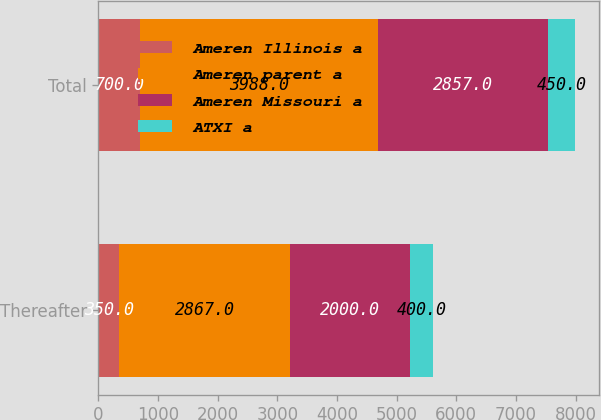<chart> <loc_0><loc_0><loc_500><loc_500><stacked_bar_chart><ecel><fcel>Thereafter<fcel>Total<nl><fcel>Ameren Illinois a<fcel>350<fcel>700<nl><fcel>Ameren parent a<fcel>2867<fcel>3988<nl><fcel>Ameren Missouri a<fcel>2000<fcel>2857<nl><fcel>ATXI a<fcel>400<fcel>450<nl></chart> 